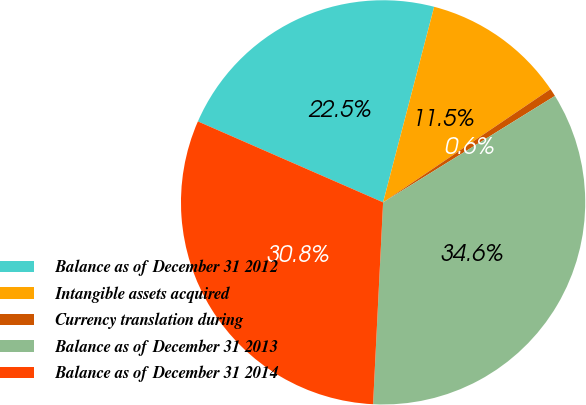<chart> <loc_0><loc_0><loc_500><loc_500><pie_chart><fcel>Balance as of December 31 2012<fcel>Intangible assets acquired<fcel>Currency translation during<fcel>Balance as of December 31 2013<fcel>Balance as of December 31 2014<nl><fcel>22.51%<fcel>11.47%<fcel>0.64%<fcel>34.62%<fcel>30.77%<nl></chart> 